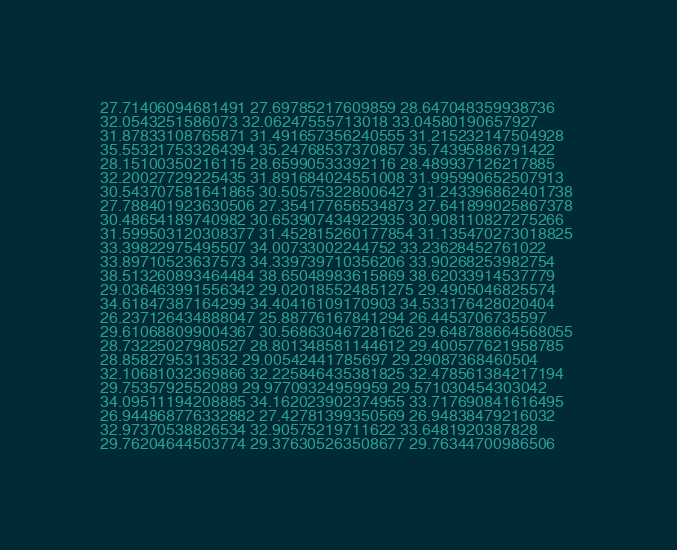<code> <loc_0><loc_0><loc_500><loc_500><_FORTRAN_>27.71406094681491 27.69785217609859 28.647048359938736 
32.0543251586073 32.06247555713018 33.04580190657927 
31.87833108765871 31.491657356240555 31.215232147504928 
35.553217533264394 35.24768537370857 35.74395886791422 
28.15100350216115 28.65990533392116 28.489937126217885 
32.20027729225435 31.891684024551008 31.995990652507913 
30.543707581641865 30.505753228006427 31.243396862401738 
27.788401923630506 27.354177656534873 27.641899025867378 
30.48654189740982 30.653907434922935 30.908110827275266 
31.599503120308377 31.452815260177854 31.135470273018825 
33.39822975495507 34.00733002244752 33.23628452761022 
33.89710523637573 34.339739710356206 33.90268253982754 
38.513260893464484 38.65048983615869 38.62033914537779 
29.036463991556342 29.020185524851275 29.4905046825574 
34.61847387164299 34.40416109170903 34.533176428020404 
26.237126434888047 25.88776167841294 26.4453706735597 
29.610688099004367 30.568630467281626 29.648788664568055 
28.73225027980527 28.801348581144612 29.400577621958785 
28.8582795313532 29.00542441785697 29.29087368460504 
32.10681032369866 32.225846435381825 32.478561384217194 
29.7535792552089 29.97709324959959 29.571030454303042 
34.09511194208885 34.162023902374955 33.717690841616495 
26.944868776332882 27.42781399350569 26.94838479216032 
32.97370538826534 32.90575219711622 33.6481920387828 
29.76204644503774 29.376305263508677 29.76344700986506 
</code> 